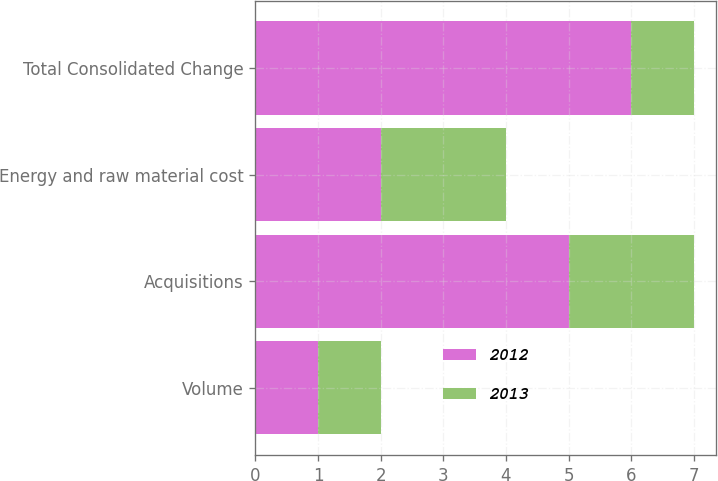Convert chart to OTSL. <chart><loc_0><loc_0><loc_500><loc_500><stacked_bar_chart><ecel><fcel>Volume<fcel>Acquisitions<fcel>Energy and raw material cost<fcel>Total Consolidated Change<nl><fcel>2012<fcel>1<fcel>5<fcel>2<fcel>6<nl><fcel>2013<fcel>1<fcel>2<fcel>2<fcel>1<nl></chart> 